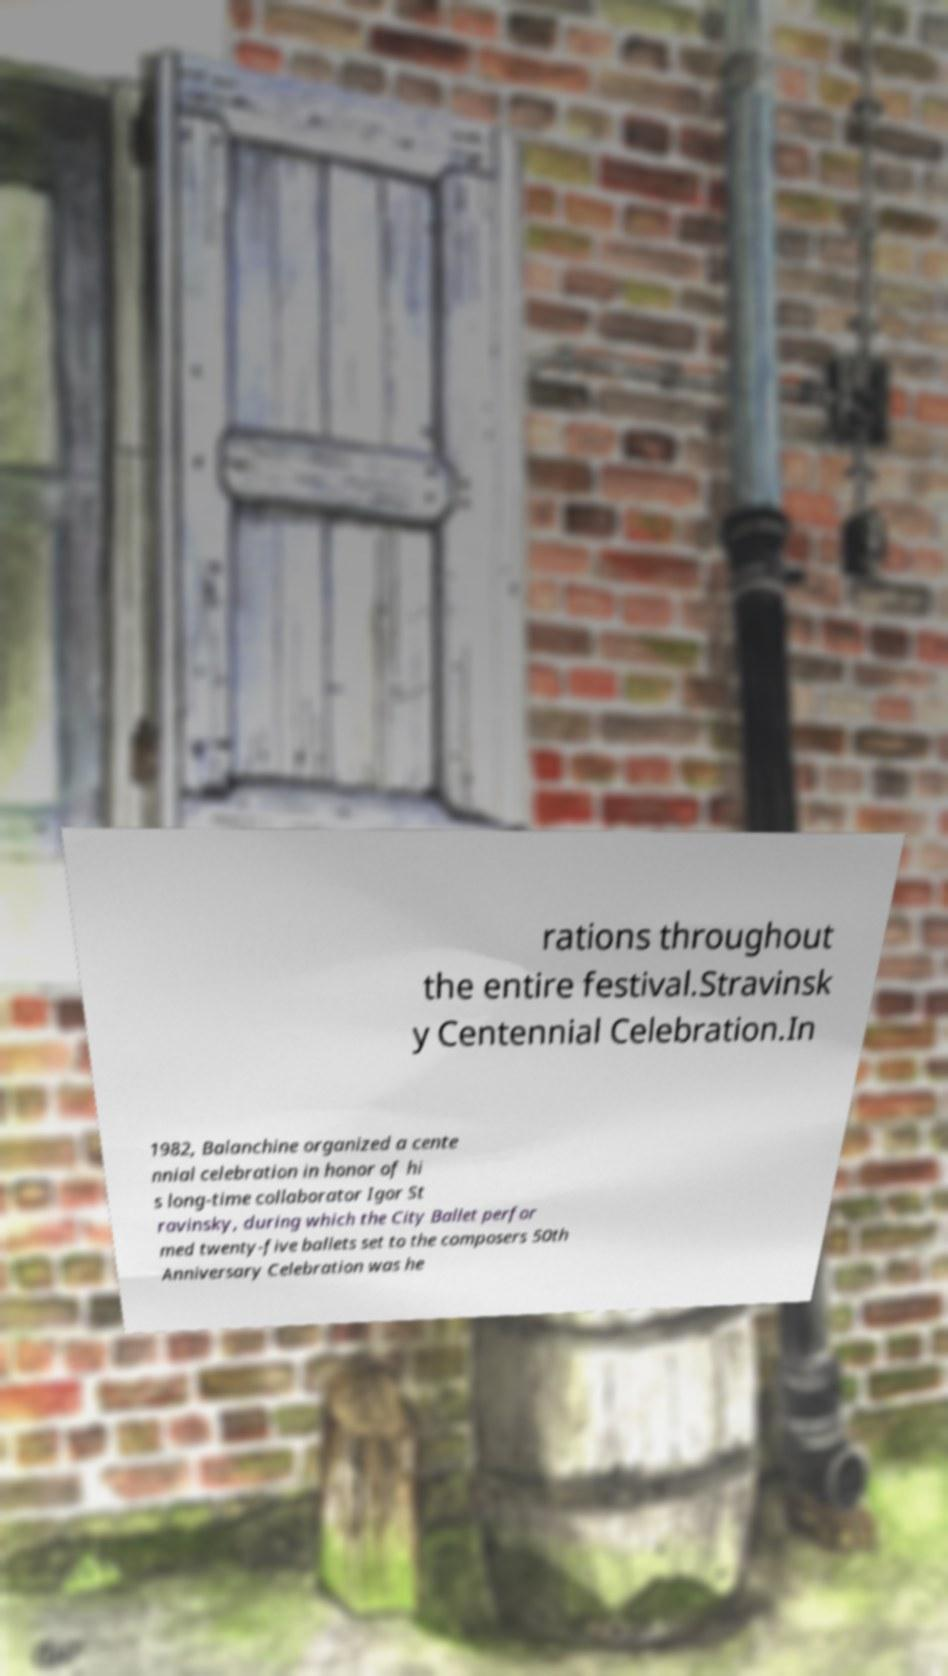Could you extract and type out the text from this image? rations throughout the entire festival.Stravinsk y Centennial Celebration.In 1982, Balanchine organized a cente nnial celebration in honor of hi s long-time collaborator Igor St ravinsky, during which the City Ballet perfor med twenty-five ballets set to the composers 50th Anniversary Celebration was he 